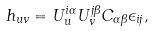<formula> <loc_0><loc_0><loc_500><loc_500>h _ { u v } = U _ { u } ^ { i \alpha } U _ { v } ^ { j \beta } C _ { \alpha \beta } \epsilon _ { i j } ,</formula> 